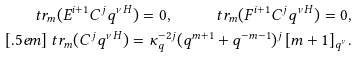<formula> <loc_0><loc_0><loc_500><loc_500>\ t r _ { m } ( E ^ { i + 1 } C ^ { j } q ^ { \nu H } ) = 0 , \quad \ t r _ { m } ( F ^ { i + 1 } C ^ { j } q ^ { \nu H } ) = 0 , \\ [ . 5 e m ] \ t r _ { m } ( C ^ { j } q ^ { \nu H } ) = \kappa _ { q } ^ { - 2 j } ( q ^ { m + 1 } + q ^ { - m - 1 } ) ^ { j } \, [ m + 1 ] _ { q ^ { \nu } } .</formula> 